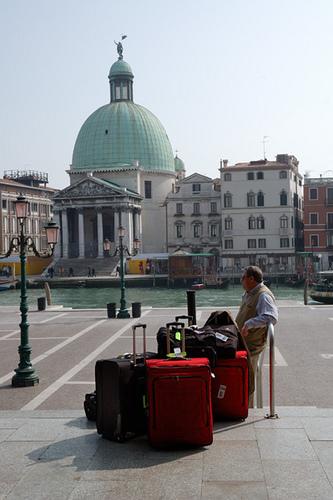How many light posts?
Quick response, please. 2. What type of structure is blue?
Quick response, please. Dome. Are there clouds in the photo?
Concise answer only. No. 